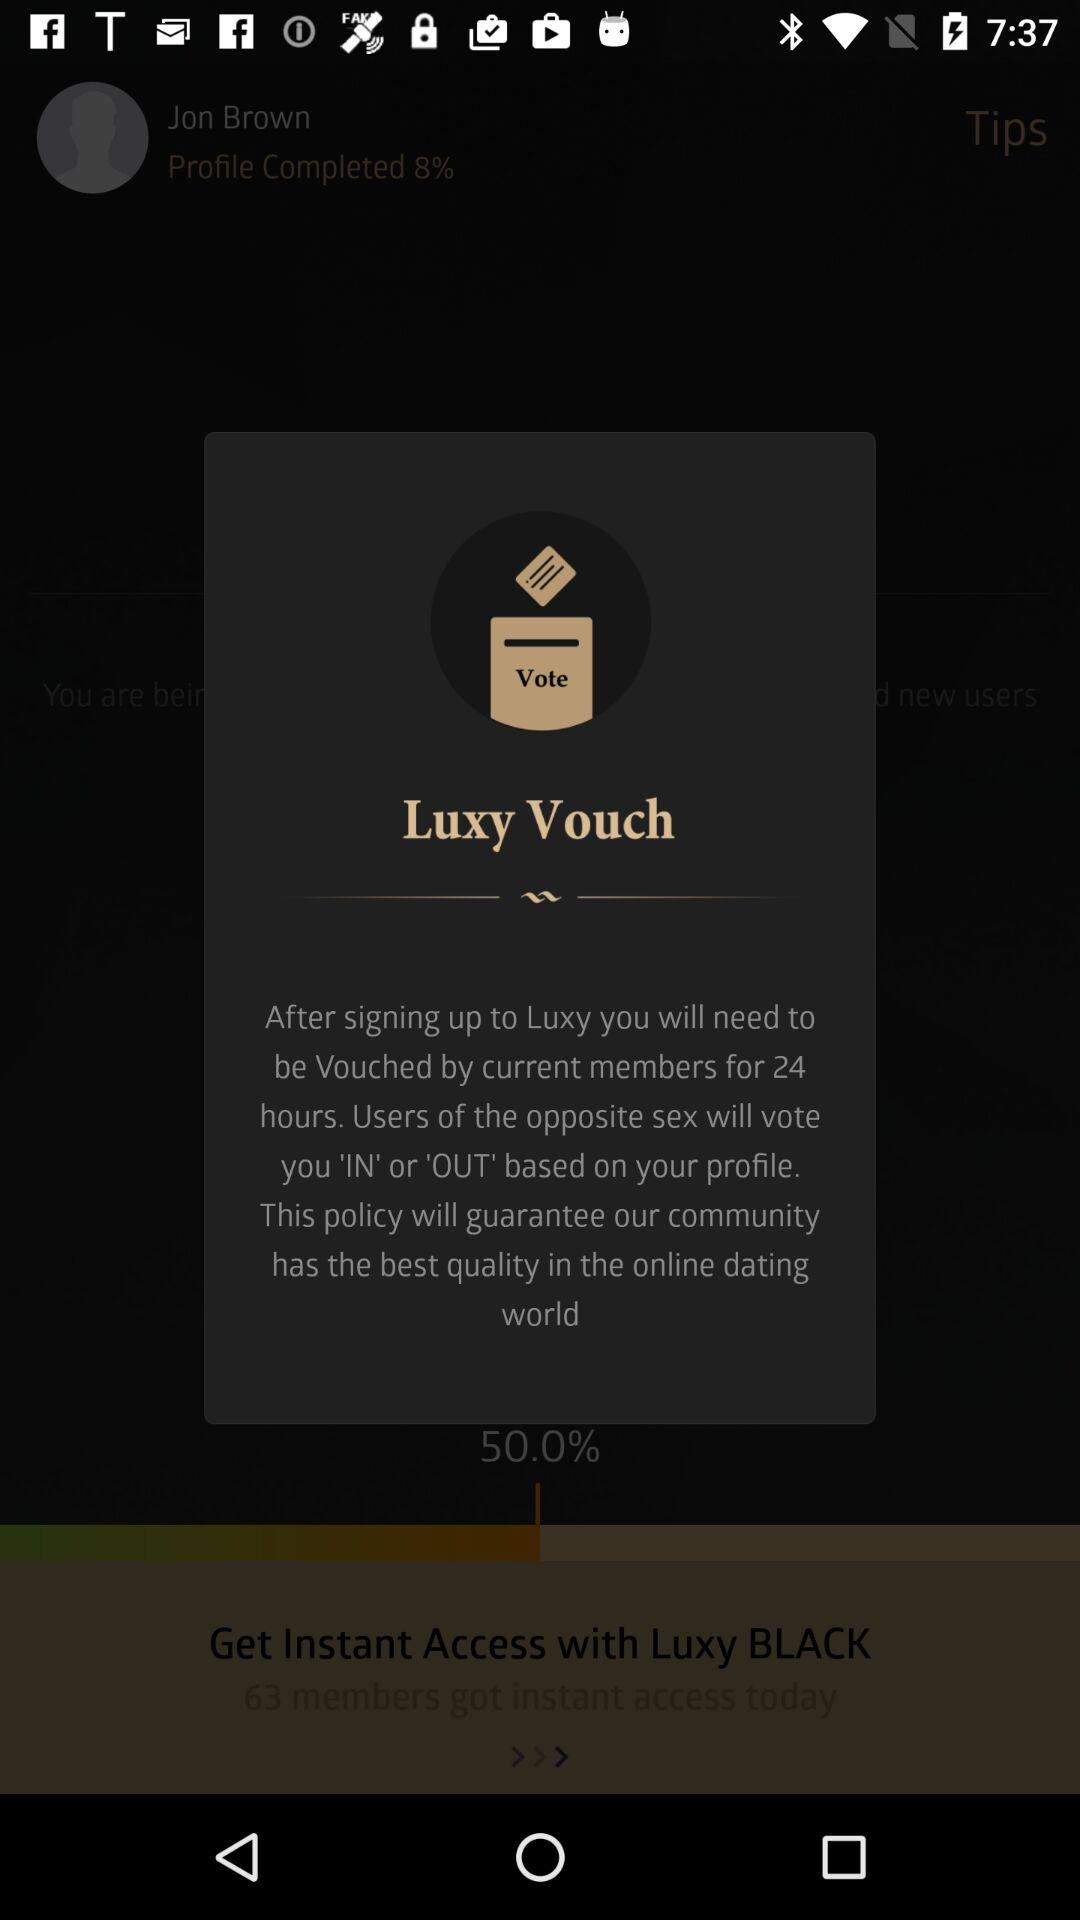How much percentage of my profile is completed?
Answer the question using a single word or phrase. 8% 